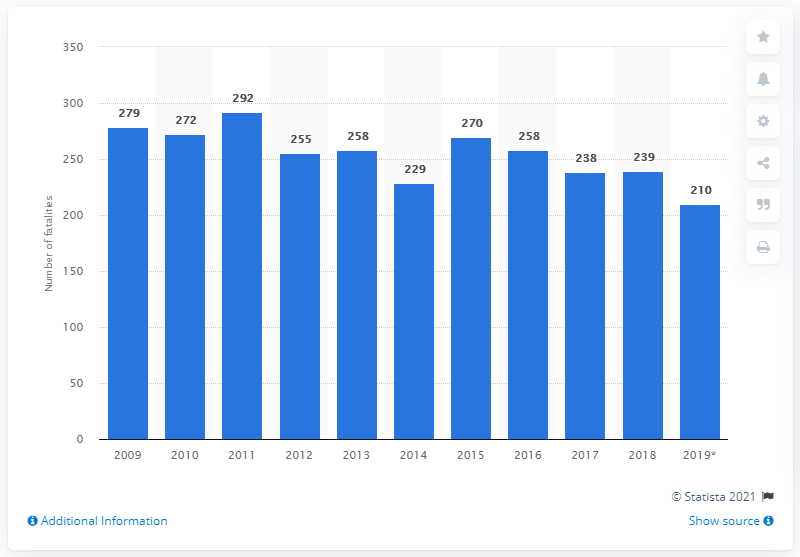Highlight a few significant elements in this photo. In 2019, there were 210 reported road casualties in Finland. 